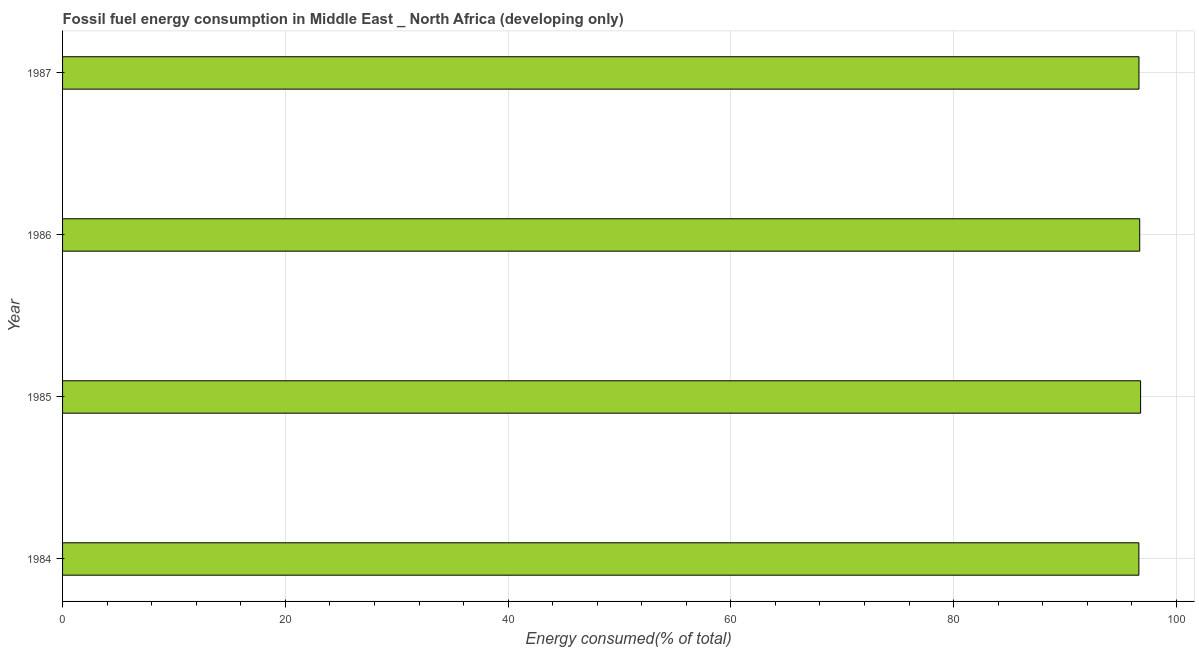Does the graph contain any zero values?
Make the answer very short. No. Does the graph contain grids?
Your response must be concise. Yes. What is the title of the graph?
Your answer should be very brief. Fossil fuel energy consumption in Middle East _ North Africa (developing only). What is the label or title of the X-axis?
Ensure brevity in your answer.  Energy consumed(% of total). What is the label or title of the Y-axis?
Offer a very short reply. Year. What is the fossil fuel energy consumption in 1985?
Your answer should be compact. 96.78. Across all years, what is the maximum fossil fuel energy consumption?
Make the answer very short. 96.78. Across all years, what is the minimum fossil fuel energy consumption?
Make the answer very short. 96.63. In which year was the fossil fuel energy consumption maximum?
Provide a short and direct response. 1985. What is the sum of the fossil fuel energy consumption?
Offer a very short reply. 386.76. What is the average fossil fuel energy consumption per year?
Provide a short and direct response. 96.69. What is the median fossil fuel energy consumption?
Your response must be concise. 96.67. In how many years, is the fossil fuel energy consumption greater than 4 %?
Provide a short and direct response. 4. Do a majority of the years between 1986 and 1987 (inclusive) have fossil fuel energy consumption greater than 52 %?
Your response must be concise. Yes. What is the difference between the highest and the second highest fossil fuel energy consumption?
Provide a succinct answer. 0.08. In how many years, is the fossil fuel energy consumption greater than the average fossil fuel energy consumption taken over all years?
Keep it short and to the point. 2. How many bars are there?
Offer a very short reply. 4. Are all the bars in the graph horizontal?
Your answer should be compact. Yes. What is the difference between two consecutive major ticks on the X-axis?
Make the answer very short. 20. Are the values on the major ticks of X-axis written in scientific E-notation?
Offer a terse response. No. What is the Energy consumed(% of total) of 1984?
Give a very brief answer. 96.63. What is the Energy consumed(% of total) in 1985?
Offer a terse response. 96.78. What is the Energy consumed(% of total) in 1986?
Your response must be concise. 96.7. What is the Energy consumed(% of total) of 1987?
Offer a very short reply. 96.64. What is the difference between the Energy consumed(% of total) in 1984 and 1985?
Make the answer very short. -0.15. What is the difference between the Energy consumed(% of total) in 1984 and 1986?
Make the answer very short. -0.07. What is the difference between the Energy consumed(% of total) in 1984 and 1987?
Give a very brief answer. -0.01. What is the difference between the Energy consumed(% of total) in 1985 and 1986?
Your answer should be compact. 0.08. What is the difference between the Energy consumed(% of total) in 1985 and 1987?
Give a very brief answer. 0.15. What is the difference between the Energy consumed(% of total) in 1986 and 1987?
Offer a very short reply. 0.07. What is the ratio of the Energy consumed(% of total) in 1984 to that in 1985?
Provide a succinct answer. 1. What is the ratio of the Energy consumed(% of total) in 1985 to that in 1987?
Give a very brief answer. 1. What is the ratio of the Energy consumed(% of total) in 1986 to that in 1987?
Provide a short and direct response. 1. 